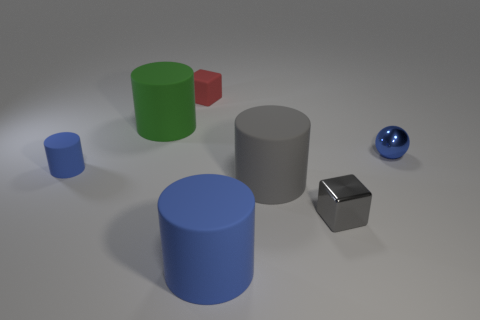Subtract all red cylinders. Subtract all brown spheres. How many cylinders are left? 4 Add 2 large gray things. How many objects exist? 9 Subtract all cylinders. How many objects are left? 3 Subtract all blue things. Subtract all small brown matte cubes. How many objects are left? 4 Add 1 rubber cubes. How many rubber cubes are left? 2 Add 5 green cylinders. How many green cylinders exist? 6 Subtract 0 red spheres. How many objects are left? 7 